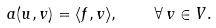<formula> <loc_0><loc_0><loc_500><loc_500>a ( u , v ) = \langle f , v \rangle , \quad \forall \, v \in V .</formula> 